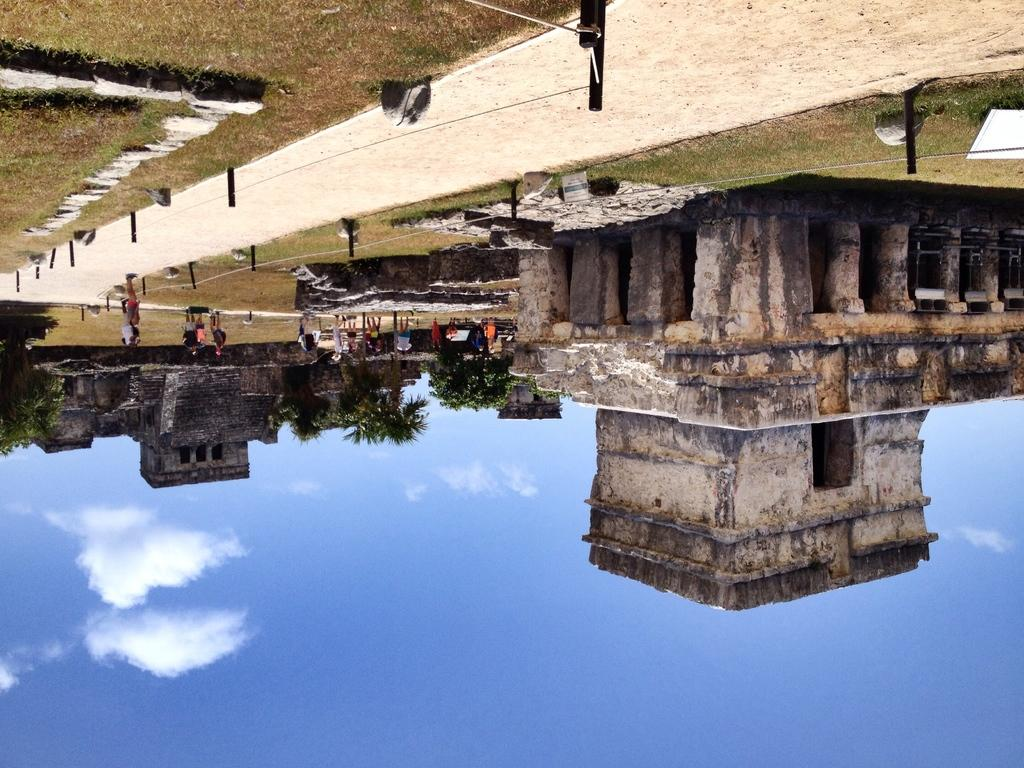What type of structures can be seen in the image? There are houses in the image. What other natural elements are present in the image? There are plants, trees, and rocks visible in the image. Are there any living beings in the image? Yes, there are people in the image. What else can be seen in the image? There are ropes visible in the image. What can be seen in the sky in the image? The sky is visible in the image. What is the feeling of the curve in the image? There is no curve present in the image, so it is not possible to describe its feeling. 